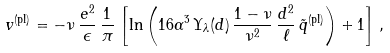Convert formula to latex. <formula><loc_0><loc_0><loc_500><loc_500>v ^ { \text {(pl)} } = - \nu \, \frac { e ^ { 2 } } { \epsilon } \, \frac { 1 } { \pi } \, \left [ \ln \left ( 1 6 \alpha ^ { 3 } \, \Upsilon _ { \lambda } ( d ) \, \frac { 1 - \nu } { \nu ^ { 2 } } \, \frac { d ^ { 2 } } { \ell } \, { \tilde { q } } ^ { \text {(pl)} } \right ) + 1 \right ] \, ,</formula> 